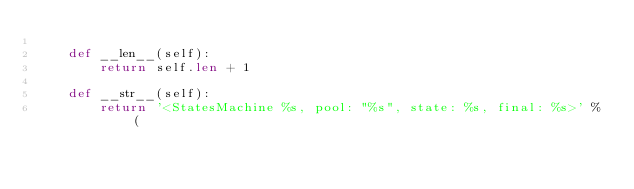<code> <loc_0><loc_0><loc_500><loc_500><_Python_>
    def __len__(self):
        return self.len + 1

    def __str__(self):
        return '<StatesMachine %s, pool: "%s", state: %s, final: %s>' % (</code> 